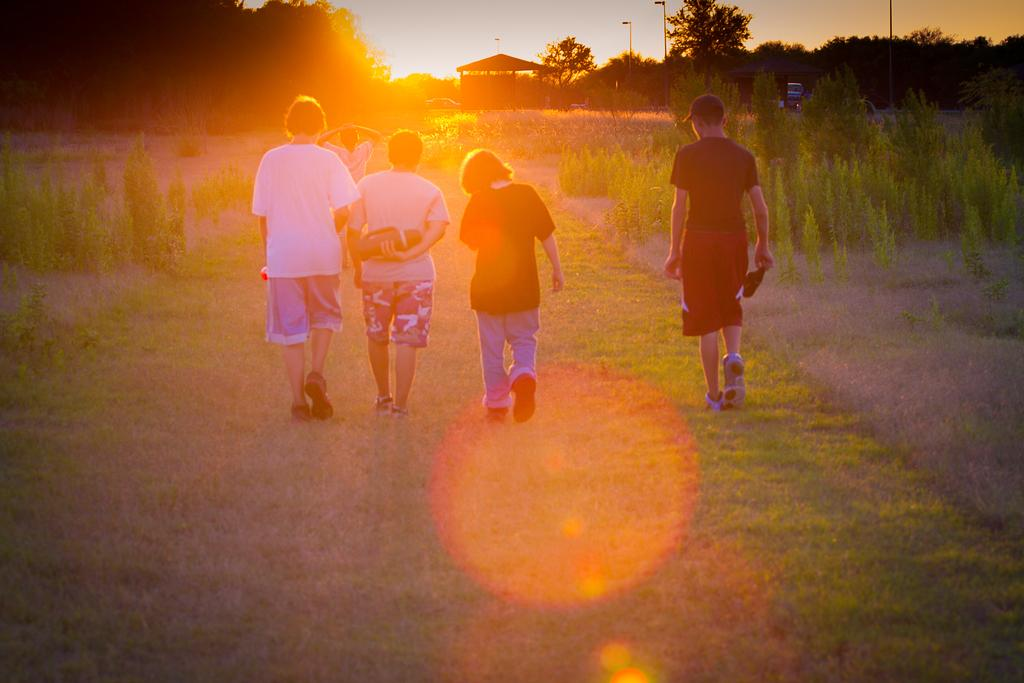What are the people in the image doing? The people in the image are walking on the grass. What structure is visible in front of the people? There is a shed in front of the people. What type of vegetation can be seen in the image? There are trees and plants in the image. Can you see any fairies playing with a pail in the image? There are no fairies or pails present in the image. What type of plastic objects can be seen in the image? There is no plastic present in the image. 